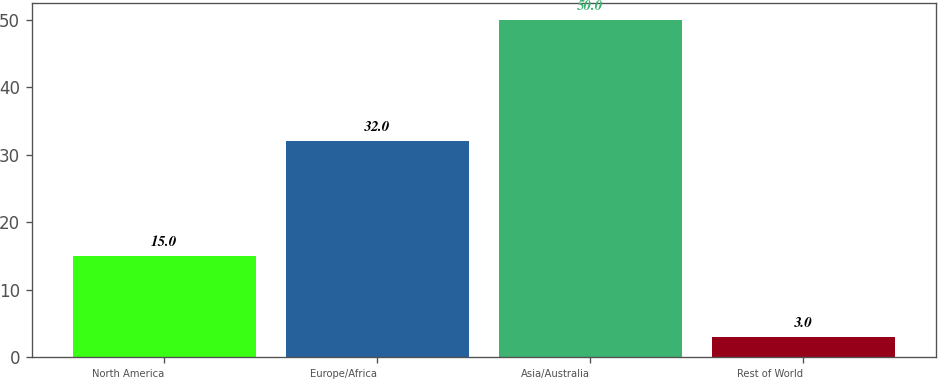Convert chart. <chart><loc_0><loc_0><loc_500><loc_500><bar_chart><fcel>North America<fcel>Europe/Africa<fcel>Asia/Australia<fcel>Rest of World<nl><fcel>15<fcel>32<fcel>50<fcel>3<nl></chart> 